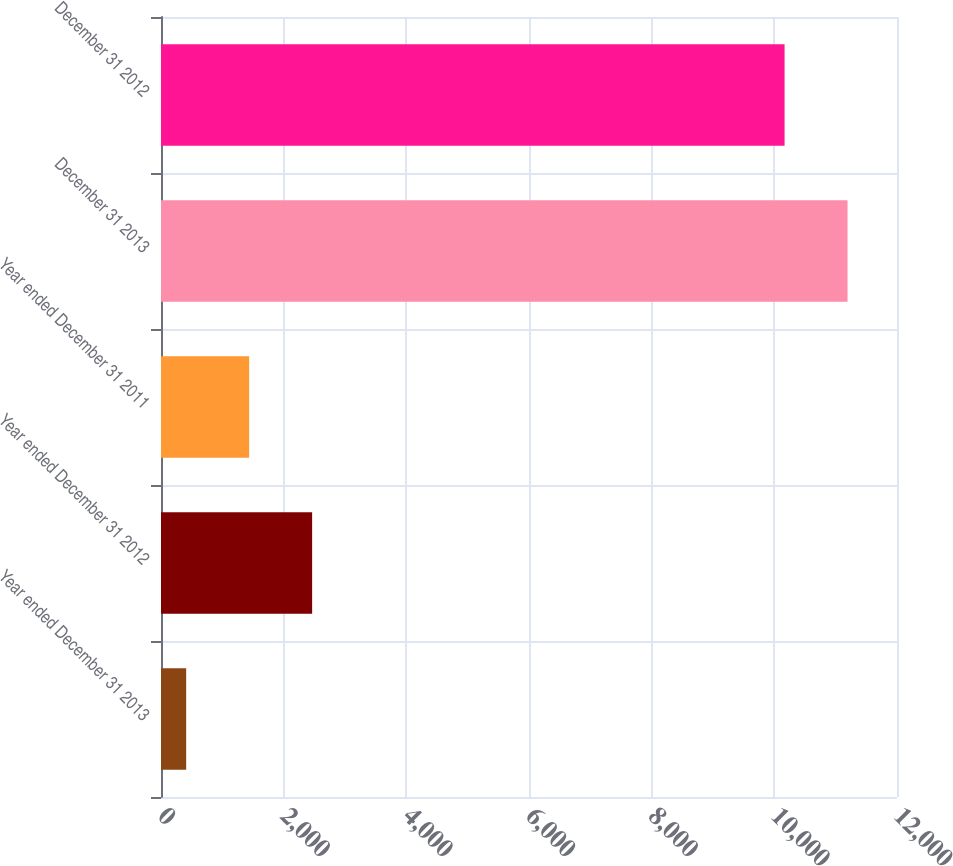<chart> <loc_0><loc_0><loc_500><loc_500><bar_chart><fcel>Year ended December 31 2013<fcel>Year ended December 31 2012<fcel>Year ended December 31 2011<fcel>December 31 2013<fcel>December 31 2012<nl><fcel>410.6<fcel>2464.1<fcel>1437.35<fcel>11193.6<fcel>10166.9<nl></chart> 